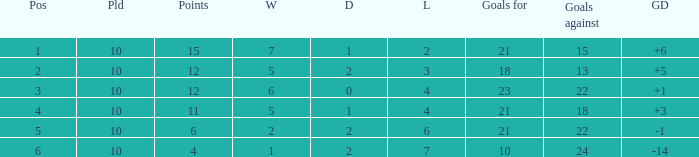Write the full table. {'header': ['Pos', 'Pld', 'Points', 'W', 'D', 'L', 'Goals for', 'Goals against', 'GD'], 'rows': [['1', '10', '15', '7', '1', '2', '21', '15', '+6'], ['2', '10', '12', '5', '2', '3', '18', '13', '+5'], ['3', '10', '12', '6', '0', '4', '23', '22', '+1'], ['4', '10', '11', '5', '1', '4', '21', '18', '+3'], ['5', '10', '6', '2', '2', '6', '21', '22', '-1'], ['6', '10', '4', '1', '2', '7', '10', '24', '-14']]} Can you tell me the sum of Goals against that has the Goals for larger than 10, and the Position of 3, and the Wins smaller than 6? None. 